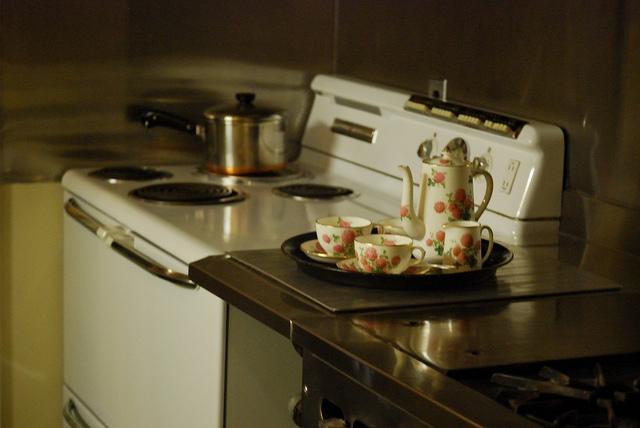What room is depicted?
Concise answer only. Kitchen. Does this kitchen need cleaning?
Concise answer only. No. Do you see a window?
Answer briefly. No. Is there a toaster on the counter?
Answer briefly. No. How many knobs are there?
Keep it brief. 3. What color is the tea set?
Give a very brief answer. White and pink. Which way is the handle positioned on the stove?
Be succinct. Left. Is the stove clean?
Answer briefly. Yes. Is there an electric outlet on the stove?
Give a very brief answer. Yes. What type of stove is this?
Short answer required. Electric. What color is the stove top?
Concise answer only. White. Is this stainless steel?
Short answer required. No. 